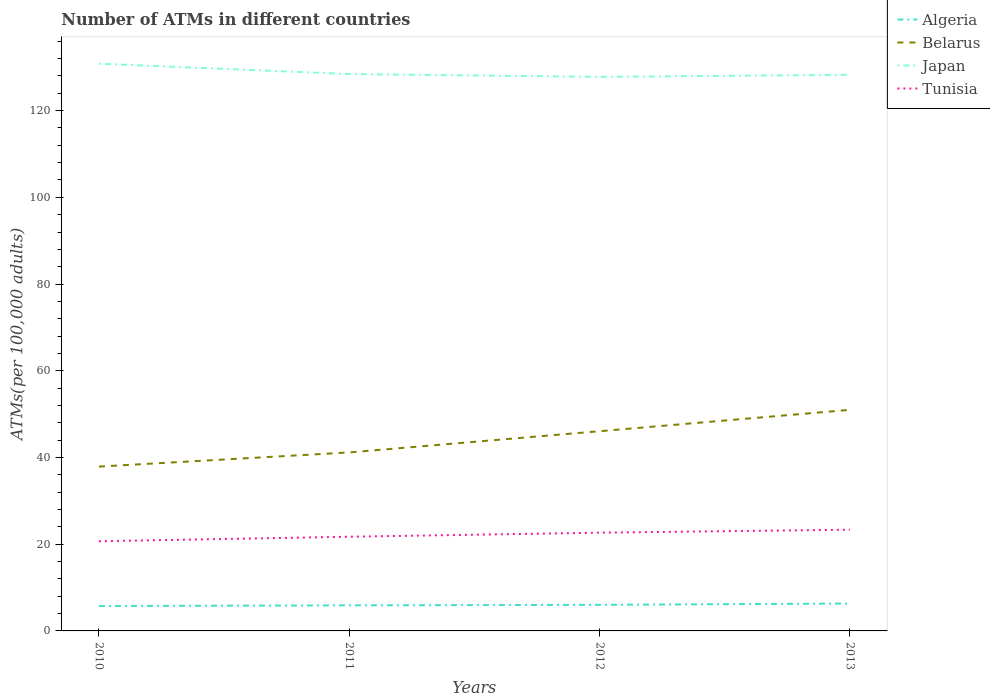Does the line corresponding to Tunisia intersect with the line corresponding to Algeria?
Keep it short and to the point. No. Across all years, what is the maximum number of ATMs in Belarus?
Make the answer very short. 37.9. What is the total number of ATMs in Algeria in the graph?
Keep it short and to the point. -0.27. What is the difference between the highest and the second highest number of ATMs in Algeria?
Keep it short and to the point. 0.58. What is the difference between the highest and the lowest number of ATMs in Algeria?
Offer a very short reply. 2. How many years are there in the graph?
Ensure brevity in your answer.  4. Does the graph contain grids?
Offer a very short reply. No. How many legend labels are there?
Keep it short and to the point. 4. What is the title of the graph?
Provide a short and direct response. Number of ATMs in different countries. What is the label or title of the Y-axis?
Offer a terse response. ATMs(per 100,0 adults). What is the ATMs(per 100,000 adults) in Algeria in 2010?
Provide a succinct answer. 5.74. What is the ATMs(per 100,000 adults) of Belarus in 2010?
Keep it short and to the point. 37.9. What is the ATMs(per 100,000 adults) of Japan in 2010?
Your answer should be compact. 130.82. What is the ATMs(per 100,000 adults) of Tunisia in 2010?
Your response must be concise. 20.68. What is the ATMs(per 100,000 adults) in Algeria in 2011?
Keep it short and to the point. 5.9. What is the ATMs(per 100,000 adults) of Belarus in 2011?
Give a very brief answer. 41.17. What is the ATMs(per 100,000 adults) in Japan in 2011?
Your response must be concise. 128.44. What is the ATMs(per 100,000 adults) of Tunisia in 2011?
Ensure brevity in your answer.  21.72. What is the ATMs(per 100,000 adults) of Algeria in 2012?
Keep it short and to the point. 6.01. What is the ATMs(per 100,000 adults) in Belarus in 2012?
Offer a very short reply. 46.06. What is the ATMs(per 100,000 adults) of Japan in 2012?
Offer a terse response. 127.79. What is the ATMs(per 100,000 adults) in Tunisia in 2012?
Your answer should be compact. 22.66. What is the ATMs(per 100,000 adults) in Algeria in 2013?
Provide a short and direct response. 6.32. What is the ATMs(per 100,000 adults) in Belarus in 2013?
Your answer should be very brief. 50.99. What is the ATMs(per 100,000 adults) of Japan in 2013?
Offer a terse response. 128.26. What is the ATMs(per 100,000 adults) of Tunisia in 2013?
Keep it short and to the point. 23.35. Across all years, what is the maximum ATMs(per 100,000 adults) of Algeria?
Your answer should be compact. 6.32. Across all years, what is the maximum ATMs(per 100,000 adults) in Belarus?
Provide a succinct answer. 50.99. Across all years, what is the maximum ATMs(per 100,000 adults) of Japan?
Give a very brief answer. 130.82. Across all years, what is the maximum ATMs(per 100,000 adults) in Tunisia?
Give a very brief answer. 23.35. Across all years, what is the minimum ATMs(per 100,000 adults) in Algeria?
Give a very brief answer. 5.74. Across all years, what is the minimum ATMs(per 100,000 adults) of Belarus?
Ensure brevity in your answer.  37.9. Across all years, what is the minimum ATMs(per 100,000 adults) of Japan?
Make the answer very short. 127.79. Across all years, what is the minimum ATMs(per 100,000 adults) of Tunisia?
Your answer should be very brief. 20.68. What is the total ATMs(per 100,000 adults) of Algeria in the graph?
Keep it short and to the point. 23.97. What is the total ATMs(per 100,000 adults) in Belarus in the graph?
Ensure brevity in your answer.  176.13. What is the total ATMs(per 100,000 adults) in Japan in the graph?
Offer a very short reply. 515.31. What is the total ATMs(per 100,000 adults) in Tunisia in the graph?
Ensure brevity in your answer.  88.41. What is the difference between the ATMs(per 100,000 adults) in Algeria in 2010 and that in 2011?
Your answer should be compact. -0.16. What is the difference between the ATMs(per 100,000 adults) of Belarus in 2010 and that in 2011?
Provide a succinct answer. -3.26. What is the difference between the ATMs(per 100,000 adults) of Japan in 2010 and that in 2011?
Provide a succinct answer. 2.39. What is the difference between the ATMs(per 100,000 adults) of Tunisia in 2010 and that in 2011?
Give a very brief answer. -1.04. What is the difference between the ATMs(per 100,000 adults) in Algeria in 2010 and that in 2012?
Ensure brevity in your answer.  -0.27. What is the difference between the ATMs(per 100,000 adults) in Belarus in 2010 and that in 2012?
Keep it short and to the point. -8.16. What is the difference between the ATMs(per 100,000 adults) in Japan in 2010 and that in 2012?
Make the answer very short. 3.04. What is the difference between the ATMs(per 100,000 adults) in Tunisia in 2010 and that in 2012?
Offer a terse response. -1.98. What is the difference between the ATMs(per 100,000 adults) of Algeria in 2010 and that in 2013?
Offer a very short reply. -0.58. What is the difference between the ATMs(per 100,000 adults) of Belarus in 2010 and that in 2013?
Keep it short and to the point. -13.08. What is the difference between the ATMs(per 100,000 adults) in Japan in 2010 and that in 2013?
Provide a short and direct response. 2.56. What is the difference between the ATMs(per 100,000 adults) of Tunisia in 2010 and that in 2013?
Your answer should be very brief. -2.67. What is the difference between the ATMs(per 100,000 adults) of Algeria in 2011 and that in 2012?
Your answer should be compact. -0.11. What is the difference between the ATMs(per 100,000 adults) in Belarus in 2011 and that in 2012?
Provide a succinct answer. -4.9. What is the difference between the ATMs(per 100,000 adults) of Japan in 2011 and that in 2012?
Provide a succinct answer. 0.65. What is the difference between the ATMs(per 100,000 adults) of Tunisia in 2011 and that in 2012?
Offer a terse response. -0.94. What is the difference between the ATMs(per 100,000 adults) in Algeria in 2011 and that in 2013?
Offer a terse response. -0.42. What is the difference between the ATMs(per 100,000 adults) in Belarus in 2011 and that in 2013?
Offer a very short reply. -9.82. What is the difference between the ATMs(per 100,000 adults) in Japan in 2011 and that in 2013?
Offer a very short reply. 0.17. What is the difference between the ATMs(per 100,000 adults) in Tunisia in 2011 and that in 2013?
Make the answer very short. -1.63. What is the difference between the ATMs(per 100,000 adults) in Algeria in 2012 and that in 2013?
Your response must be concise. -0.31. What is the difference between the ATMs(per 100,000 adults) in Belarus in 2012 and that in 2013?
Offer a terse response. -4.93. What is the difference between the ATMs(per 100,000 adults) in Japan in 2012 and that in 2013?
Your answer should be compact. -0.47. What is the difference between the ATMs(per 100,000 adults) of Tunisia in 2012 and that in 2013?
Your response must be concise. -0.69. What is the difference between the ATMs(per 100,000 adults) of Algeria in 2010 and the ATMs(per 100,000 adults) of Belarus in 2011?
Give a very brief answer. -35.43. What is the difference between the ATMs(per 100,000 adults) of Algeria in 2010 and the ATMs(per 100,000 adults) of Japan in 2011?
Offer a very short reply. -122.7. What is the difference between the ATMs(per 100,000 adults) of Algeria in 2010 and the ATMs(per 100,000 adults) of Tunisia in 2011?
Your response must be concise. -15.98. What is the difference between the ATMs(per 100,000 adults) of Belarus in 2010 and the ATMs(per 100,000 adults) of Japan in 2011?
Keep it short and to the point. -90.53. What is the difference between the ATMs(per 100,000 adults) of Belarus in 2010 and the ATMs(per 100,000 adults) of Tunisia in 2011?
Provide a short and direct response. 16.18. What is the difference between the ATMs(per 100,000 adults) in Japan in 2010 and the ATMs(per 100,000 adults) in Tunisia in 2011?
Keep it short and to the point. 109.1. What is the difference between the ATMs(per 100,000 adults) in Algeria in 2010 and the ATMs(per 100,000 adults) in Belarus in 2012?
Keep it short and to the point. -40.33. What is the difference between the ATMs(per 100,000 adults) of Algeria in 2010 and the ATMs(per 100,000 adults) of Japan in 2012?
Your answer should be very brief. -122.05. What is the difference between the ATMs(per 100,000 adults) of Algeria in 2010 and the ATMs(per 100,000 adults) of Tunisia in 2012?
Your answer should be compact. -16.92. What is the difference between the ATMs(per 100,000 adults) in Belarus in 2010 and the ATMs(per 100,000 adults) in Japan in 2012?
Make the answer very short. -89.88. What is the difference between the ATMs(per 100,000 adults) in Belarus in 2010 and the ATMs(per 100,000 adults) in Tunisia in 2012?
Give a very brief answer. 15.24. What is the difference between the ATMs(per 100,000 adults) in Japan in 2010 and the ATMs(per 100,000 adults) in Tunisia in 2012?
Your response must be concise. 108.17. What is the difference between the ATMs(per 100,000 adults) in Algeria in 2010 and the ATMs(per 100,000 adults) in Belarus in 2013?
Offer a very short reply. -45.25. What is the difference between the ATMs(per 100,000 adults) of Algeria in 2010 and the ATMs(per 100,000 adults) of Japan in 2013?
Provide a short and direct response. -122.52. What is the difference between the ATMs(per 100,000 adults) of Algeria in 2010 and the ATMs(per 100,000 adults) of Tunisia in 2013?
Your response must be concise. -17.61. What is the difference between the ATMs(per 100,000 adults) of Belarus in 2010 and the ATMs(per 100,000 adults) of Japan in 2013?
Your response must be concise. -90.36. What is the difference between the ATMs(per 100,000 adults) in Belarus in 2010 and the ATMs(per 100,000 adults) in Tunisia in 2013?
Ensure brevity in your answer.  14.56. What is the difference between the ATMs(per 100,000 adults) in Japan in 2010 and the ATMs(per 100,000 adults) in Tunisia in 2013?
Make the answer very short. 107.48. What is the difference between the ATMs(per 100,000 adults) of Algeria in 2011 and the ATMs(per 100,000 adults) of Belarus in 2012?
Provide a succinct answer. -40.16. What is the difference between the ATMs(per 100,000 adults) of Algeria in 2011 and the ATMs(per 100,000 adults) of Japan in 2012?
Give a very brief answer. -121.89. What is the difference between the ATMs(per 100,000 adults) of Algeria in 2011 and the ATMs(per 100,000 adults) of Tunisia in 2012?
Offer a very short reply. -16.76. What is the difference between the ATMs(per 100,000 adults) of Belarus in 2011 and the ATMs(per 100,000 adults) of Japan in 2012?
Make the answer very short. -86.62. What is the difference between the ATMs(per 100,000 adults) of Belarus in 2011 and the ATMs(per 100,000 adults) of Tunisia in 2012?
Your answer should be very brief. 18.51. What is the difference between the ATMs(per 100,000 adults) in Japan in 2011 and the ATMs(per 100,000 adults) in Tunisia in 2012?
Provide a succinct answer. 105.78. What is the difference between the ATMs(per 100,000 adults) in Algeria in 2011 and the ATMs(per 100,000 adults) in Belarus in 2013?
Provide a short and direct response. -45.09. What is the difference between the ATMs(per 100,000 adults) of Algeria in 2011 and the ATMs(per 100,000 adults) of Japan in 2013?
Your response must be concise. -122.36. What is the difference between the ATMs(per 100,000 adults) of Algeria in 2011 and the ATMs(per 100,000 adults) of Tunisia in 2013?
Your answer should be very brief. -17.45. What is the difference between the ATMs(per 100,000 adults) in Belarus in 2011 and the ATMs(per 100,000 adults) in Japan in 2013?
Your response must be concise. -87.09. What is the difference between the ATMs(per 100,000 adults) of Belarus in 2011 and the ATMs(per 100,000 adults) of Tunisia in 2013?
Provide a short and direct response. 17.82. What is the difference between the ATMs(per 100,000 adults) in Japan in 2011 and the ATMs(per 100,000 adults) in Tunisia in 2013?
Make the answer very short. 105.09. What is the difference between the ATMs(per 100,000 adults) of Algeria in 2012 and the ATMs(per 100,000 adults) of Belarus in 2013?
Provide a short and direct response. -44.98. What is the difference between the ATMs(per 100,000 adults) in Algeria in 2012 and the ATMs(per 100,000 adults) in Japan in 2013?
Provide a succinct answer. -122.25. What is the difference between the ATMs(per 100,000 adults) of Algeria in 2012 and the ATMs(per 100,000 adults) of Tunisia in 2013?
Offer a very short reply. -17.34. What is the difference between the ATMs(per 100,000 adults) of Belarus in 2012 and the ATMs(per 100,000 adults) of Japan in 2013?
Offer a terse response. -82.2. What is the difference between the ATMs(per 100,000 adults) of Belarus in 2012 and the ATMs(per 100,000 adults) of Tunisia in 2013?
Offer a terse response. 22.72. What is the difference between the ATMs(per 100,000 adults) of Japan in 2012 and the ATMs(per 100,000 adults) of Tunisia in 2013?
Your answer should be compact. 104.44. What is the average ATMs(per 100,000 adults) in Algeria per year?
Your response must be concise. 5.99. What is the average ATMs(per 100,000 adults) in Belarus per year?
Provide a short and direct response. 44.03. What is the average ATMs(per 100,000 adults) of Japan per year?
Provide a short and direct response. 128.83. What is the average ATMs(per 100,000 adults) in Tunisia per year?
Provide a short and direct response. 22.1. In the year 2010, what is the difference between the ATMs(per 100,000 adults) in Algeria and ATMs(per 100,000 adults) in Belarus?
Offer a terse response. -32.17. In the year 2010, what is the difference between the ATMs(per 100,000 adults) of Algeria and ATMs(per 100,000 adults) of Japan?
Make the answer very short. -125.09. In the year 2010, what is the difference between the ATMs(per 100,000 adults) of Algeria and ATMs(per 100,000 adults) of Tunisia?
Your answer should be compact. -14.95. In the year 2010, what is the difference between the ATMs(per 100,000 adults) in Belarus and ATMs(per 100,000 adults) in Japan?
Keep it short and to the point. -92.92. In the year 2010, what is the difference between the ATMs(per 100,000 adults) of Belarus and ATMs(per 100,000 adults) of Tunisia?
Your answer should be compact. 17.22. In the year 2010, what is the difference between the ATMs(per 100,000 adults) of Japan and ATMs(per 100,000 adults) of Tunisia?
Offer a terse response. 110.14. In the year 2011, what is the difference between the ATMs(per 100,000 adults) of Algeria and ATMs(per 100,000 adults) of Belarus?
Your response must be concise. -35.27. In the year 2011, what is the difference between the ATMs(per 100,000 adults) in Algeria and ATMs(per 100,000 adults) in Japan?
Your response must be concise. -122.53. In the year 2011, what is the difference between the ATMs(per 100,000 adults) in Algeria and ATMs(per 100,000 adults) in Tunisia?
Make the answer very short. -15.82. In the year 2011, what is the difference between the ATMs(per 100,000 adults) of Belarus and ATMs(per 100,000 adults) of Japan?
Ensure brevity in your answer.  -87.27. In the year 2011, what is the difference between the ATMs(per 100,000 adults) of Belarus and ATMs(per 100,000 adults) of Tunisia?
Offer a terse response. 19.45. In the year 2011, what is the difference between the ATMs(per 100,000 adults) in Japan and ATMs(per 100,000 adults) in Tunisia?
Offer a very short reply. 106.71. In the year 2012, what is the difference between the ATMs(per 100,000 adults) in Algeria and ATMs(per 100,000 adults) in Belarus?
Your answer should be compact. -40.05. In the year 2012, what is the difference between the ATMs(per 100,000 adults) of Algeria and ATMs(per 100,000 adults) of Japan?
Your response must be concise. -121.78. In the year 2012, what is the difference between the ATMs(per 100,000 adults) in Algeria and ATMs(per 100,000 adults) in Tunisia?
Your answer should be compact. -16.65. In the year 2012, what is the difference between the ATMs(per 100,000 adults) of Belarus and ATMs(per 100,000 adults) of Japan?
Provide a succinct answer. -81.72. In the year 2012, what is the difference between the ATMs(per 100,000 adults) of Belarus and ATMs(per 100,000 adults) of Tunisia?
Ensure brevity in your answer.  23.4. In the year 2012, what is the difference between the ATMs(per 100,000 adults) of Japan and ATMs(per 100,000 adults) of Tunisia?
Ensure brevity in your answer.  105.13. In the year 2013, what is the difference between the ATMs(per 100,000 adults) of Algeria and ATMs(per 100,000 adults) of Belarus?
Keep it short and to the point. -44.67. In the year 2013, what is the difference between the ATMs(per 100,000 adults) of Algeria and ATMs(per 100,000 adults) of Japan?
Offer a terse response. -121.94. In the year 2013, what is the difference between the ATMs(per 100,000 adults) of Algeria and ATMs(per 100,000 adults) of Tunisia?
Give a very brief answer. -17.03. In the year 2013, what is the difference between the ATMs(per 100,000 adults) in Belarus and ATMs(per 100,000 adults) in Japan?
Offer a terse response. -77.27. In the year 2013, what is the difference between the ATMs(per 100,000 adults) in Belarus and ATMs(per 100,000 adults) in Tunisia?
Provide a short and direct response. 27.64. In the year 2013, what is the difference between the ATMs(per 100,000 adults) in Japan and ATMs(per 100,000 adults) in Tunisia?
Offer a terse response. 104.91. What is the ratio of the ATMs(per 100,000 adults) of Algeria in 2010 to that in 2011?
Your answer should be very brief. 0.97. What is the ratio of the ATMs(per 100,000 adults) in Belarus in 2010 to that in 2011?
Make the answer very short. 0.92. What is the ratio of the ATMs(per 100,000 adults) in Japan in 2010 to that in 2011?
Offer a very short reply. 1.02. What is the ratio of the ATMs(per 100,000 adults) of Tunisia in 2010 to that in 2011?
Offer a terse response. 0.95. What is the ratio of the ATMs(per 100,000 adults) in Algeria in 2010 to that in 2012?
Make the answer very short. 0.95. What is the ratio of the ATMs(per 100,000 adults) in Belarus in 2010 to that in 2012?
Make the answer very short. 0.82. What is the ratio of the ATMs(per 100,000 adults) in Japan in 2010 to that in 2012?
Keep it short and to the point. 1.02. What is the ratio of the ATMs(per 100,000 adults) in Tunisia in 2010 to that in 2012?
Provide a succinct answer. 0.91. What is the ratio of the ATMs(per 100,000 adults) of Algeria in 2010 to that in 2013?
Provide a short and direct response. 0.91. What is the ratio of the ATMs(per 100,000 adults) of Belarus in 2010 to that in 2013?
Your response must be concise. 0.74. What is the ratio of the ATMs(per 100,000 adults) of Japan in 2010 to that in 2013?
Offer a terse response. 1.02. What is the ratio of the ATMs(per 100,000 adults) in Tunisia in 2010 to that in 2013?
Give a very brief answer. 0.89. What is the ratio of the ATMs(per 100,000 adults) of Algeria in 2011 to that in 2012?
Your answer should be compact. 0.98. What is the ratio of the ATMs(per 100,000 adults) in Belarus in 2011 to that in 2012?
Offer a very short reply. 0.89. What is the ratio of the ATMs(per 100,000 adults) of Tunisia in 2011 to that in 2012?
Provide a succinct answer. 0.96. What is the ratio of the ATMs(per 100,000 adults) of Algeria in 2011 to that in 2013?
Keep it short and to the point. 0.93. What is the ratio of the ATMs(per 100,000 adults) of Belarus in 2011 to that in 2013?
Make the answer very short. 0.81. What is the ratio of the ATMs(per 100,000 adults) of Japan in 2011 to that in 2013?
Provide a short and direct response. 1. What is the ratio of the ATMs(per 100,000 adults) of Tunisia in 2011 to that in 2013?
Offer a terse response. 0.93. What is the ratio of the ATMs(per 100,000 adults) in Algeria in 2012 to that in 2013?
Your answer should be very brief. 0.95. What is the ratio of the ATMs(per 100,000 adults) in Belarus in 2012 to that in 2013?
Give a very brief answer. 0.9. What is the ratio of the ATMs(per 100,000 adults) in Japan in 2012 to that in 2013?
Provide a short and direct response. 1. What is the ratio of the ATMs(per 100,000 adults) in Tunisia in 2012 to that in 2013?
Offer a very short reply. 0.97. What is the difference between the highest and the second highest ATMs(per 100,000 adults) in Algeria?
Your response must be concise. 0.31. What is the difference between the highest and the second highest ATMs(per 100,000 adults) in Belarus?
Ensure brevity in your answer.  4.93. What is the difference between the highest and the second highest ATMs(per 100,000 adults) of Japan?
Provide a succinct answer. 2.39. What is the difference between the highest and the second highest ATMs(per 100,000 adults) of Tunisia?
Your answer should be compact. 0.69. What is the difference between the highest and the lowest ATMs(per 100,000 adults) of Algeria?
Give a very brief answer. 0.58. What is the difference between the highest and the lowest ATMs(per 100,000 adults) in Belarus?
Provide a succinct answer. 13.08. What is the difference between the highest and the lowest ATMs(per 100,000 adults) in Japan?
Your answer should be compact. 3.04. What is the difference between the highest and the lowest ATMs(per 100,000 adults) of Tunisia?
Offer a terse response. 2.67. 